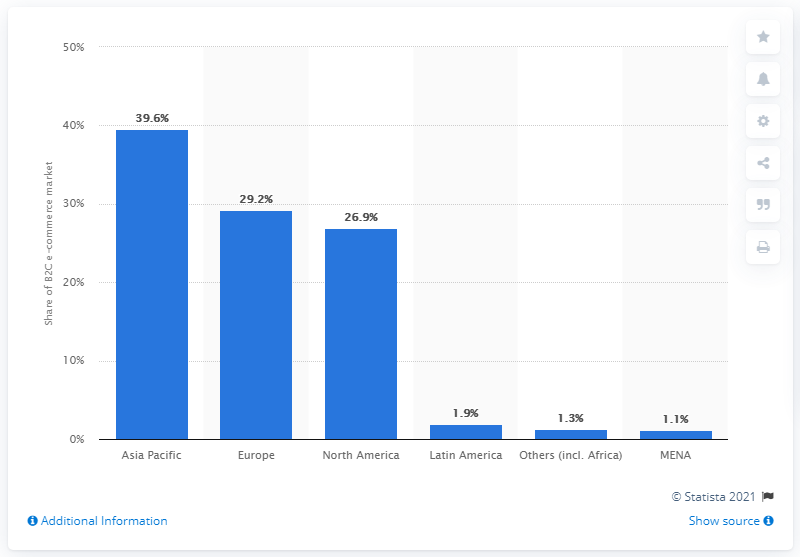Identify some key points in this picture. In 2014, the Asia Pacific region accounted for 39.6% of the global B2C e-commerce market's turnover. According to data from 2014, the Asia Pacific region accounted for 39.6% of the worldwide B2C e-commerce market turnover. 